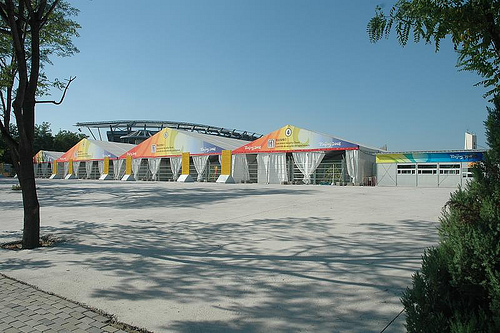<image>
Can you confirm if the tree is behind the building? No. The tree is not behind the building. From this viewpoint, the tree appears to be positioned elsewhere in the scene. 